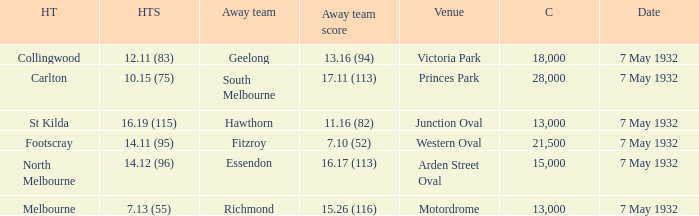What is the largest crowd with Away team score of 13.16 (94)? 18000.0. Parse the table in full. {'header': ['HT', 'HTS', 'Away team', 'Away team score', 'Venue', 'C', 'Date'], 'rows': [['Collingwood', '12.11 (83)', 'Geelong', '13.16 (94)', 'Victoria Park', '18,000', '7 May 1932'], ['Carlton', '10.15 (75)', 'South Melbourne', '17.11 (113)', 'Princes Park', '28,000', '7 May 1932'], ['St Kilda', '16.19 (115)', 'Hawthorn', '11.16 (82)', 'Junction Oval', '13,000', '7 May 1932'], ['Footscray', '14.11 (95)', 'Fitzroy', '7.10 (52)', 'Western Oval', '21,500', '7 May 1932'], ['North Melbourne', '14.12 (96)', 'Essendon', '16.17 (113)', 'Arden Street Oval', '15,000', '7 May 1932'], ['Melbourne', '7.13 (55)', 'Richmond', '15.26 (116)', 'Motordrome', '13,000', '7 May 1932']]} 